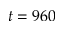Convert formula to latex. <formula><loc_0><loc_0><loc_500><loc_500>t = 9 6 0</formula> 